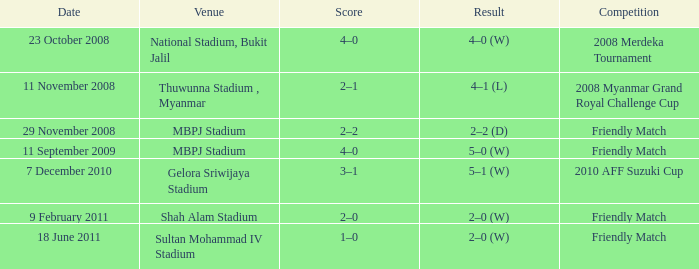What is the Venue of the Competition with a Result of 2–2 (d)? MBPJ Stadium. 